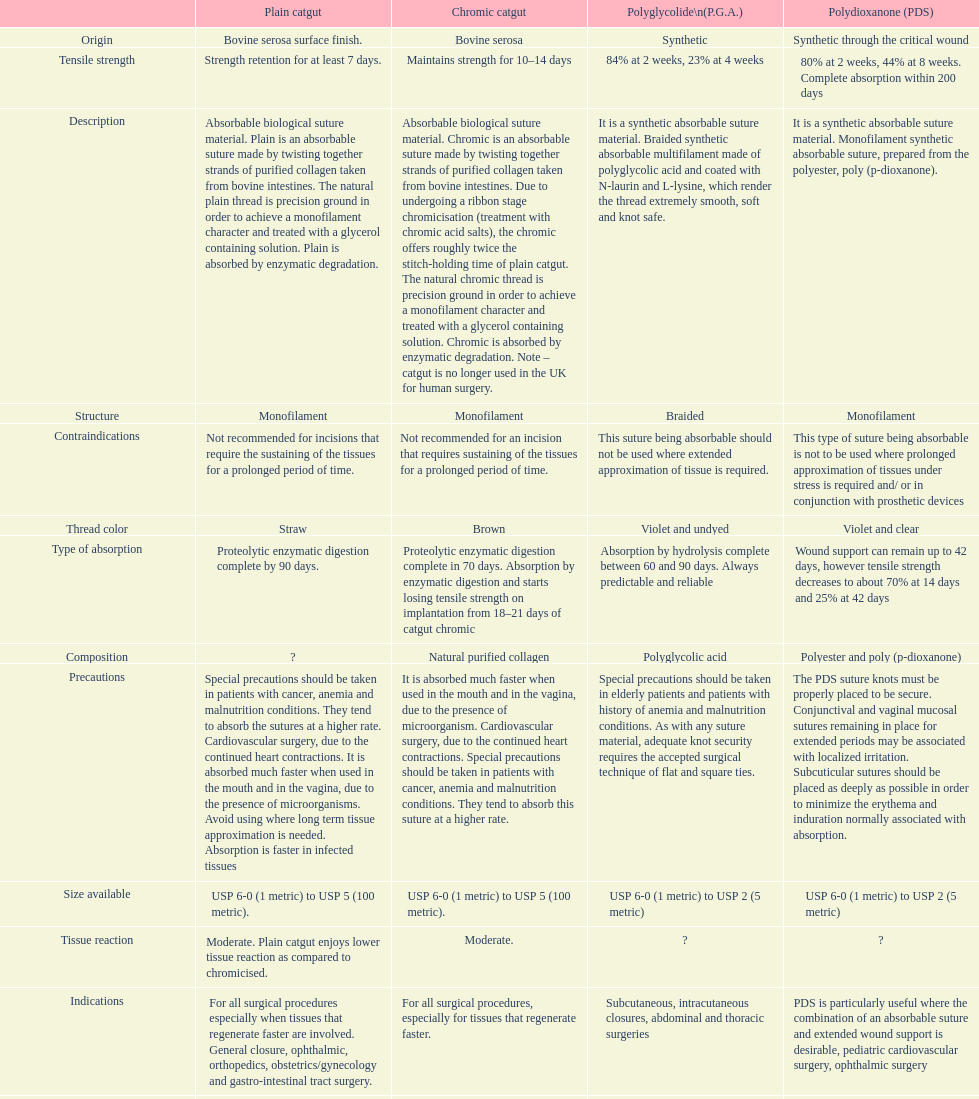I'm looking to parse the entire table for insights. Could you assist me with that? {'header': ['', 'Plain catgut', 'Chromic catgut', 'Polyglycolide\\n(P.G.A.)', 'Polydioxanone (PDS)'], 'rows': [['Origin', 'Bovine serosa surface finish.', 'Bovine serosa', 'Synthetic', 'Synthetic through the critical wound'], ['Tensile strength', 'Strength retention for at least 7 days.', 'Maintains strength for 10–14 days', '84% at 2 weeks, 23% at 4 weeks', '80% at 2 weeks, 44% at 8 weeks. Complete absorption within 200 days'], ['Description', 'Absorbable biological suture material. Plain is an absorbable suture made by twisting together strands of purified collagen taken from bovine intestines. The natural plain thread is precision ground in order to achieve a monofilament character and treated with a glycerol containing solution. Plain is absorbed by enzymatic degradation.', 'Absorbable biological suture material. Chromic is an absorbable suture made by twisting together strands of purified collagen taken from bovine intestines. Due to undergoing a ribbon stage chromicisation (treatment with chromic acid salts), the chromic offers roughly twice the stitch-holding time of plain catgut. The natural chromic thread is precision ground in order to achieve a monofilament character and treated with a glycerol containing solution. Chromic is absorbed by enzymatic degradation. Note – catgut is no longer used in the UK for human surgery.', 'It is a synthetic absorbable suture material. Braided synthetic absorbable multifilament made of polyglycolic acid and coated with N-laurin and L-lysine, which render the thread extremely smooth, soft and knot safe.', 'It is a synthetic absorbable suture material. Monofilament synthetic absorbable suture, prepared from the polyester, poly (p-dioxanone).'], ['Structure', 'Monofilament', 'Monofilament', 'Braided', 'Monofilament'], ['Contraindications', 'Not recommended for incisions that require the sustaining of the tissues for a prolonged period of time.', 'Not recommended for an incision that requires sustaining of the tissues for a prolonged period of time.', 'This suture being absorbable should not be used where extended approximation of tissue is required.', 'This type of suture being absorbable is not to be used where prolonged approximation of tissues under stress is required and/ or in conjunction with prosthetic devices'], ['Thread color', 'Straw', 'Brown', 'Violet and undyed', 'Violet and clear'], ['Type of absorption', 'Proteolytic enzymatic digestion complete by 90 days.', 'Proteolytic enzymatic digestion complete in 70 days. Absorption by enzymatic digestion and starts losing tensile strength on implantation from 18–21 days of catgut chromic', 'Absorption by hydrolysis complete between 60 and 90 days. Always predictable and reliable', 'Wound support can remain up to 42 days, however tensile strength decreases to about 70% at 14 days and 25% at 42 days'], ['Composition', '?', 'Natural purified collagen', 'Polyglycolic acid', 'Polyester and poly (p-dioxanone)'], ['Precautions', 'Special precautions should be taken in patients with cancer, anemia and malnutrition conditions. They tend to absorb the sutures at a higher rate. Cardiovascular surgery, due to the continued heart contractions. It is absorbed much faster when used in the mouth and in the vagina, due to the presence of microorganisms. Avoid using where long term tissue approximation is needed. Absorption is faster in infected tissues', 'It is absorbed much faster when used in the mouth and in the vagina, due to the presence of microorganism. Cardiovascular surgery, due to the continued heart contractions. Special precautions should be taken in patients with cancer, anemia and malnutrition conditions. They tend to absorb this suture at a higher rate.', 'Special precautions should be taken in elderly patients and patients with history of anemia and malnutrition conditions. As with any suture material, adequate knot security requires the accepted surgical technique of flat and square ties.', 'The PDS suture knots must be properly placed to be secure. Conjunctival and vaginal mucosal sutures remaining in place for extended periods may be associated with localized irritation. Subcuticular sutures should be placed as deeply as possible in order to minimize the erythema and induration normally associated with absorption.'], ['Size available', 'USP 6-0 (1 metric) to USP 5 (100 metric).', 'USP 6-0 (1 metric) to USP 5 (100 metric).', 'USP 6-0 (1 metric) to USP 2 (5 metric)', 'USP 6-0 (1 metric) to USP 2 (5 metric)'], ['Tissue reaction', 'Moderate. Plain catgut enjoys lower tissue reaction as compared to chromicised.', 'Moderate.', '?', '?'], ['Indications', 'For all surgical procedures especially when tissues that regenerate faster are involved. General closure, ophthalmic, orthopedics, obstetrics/gynecology and gastro-intestinal tract surgery.', 'For all surgical procedures, especially for tissues that regenerate faster.', 'Subcutaneous, intracutaneous closures, abdominal and thoracic surgeries', 'PDS is particularly useful where the combination of an absorbable suture and extended wound support is desirable, pediatric cardiovascular surgery, ophthalmic surgery'], ['Treatment', '?', 'Treatment with a glycerol containing solution and chromic acid salts', 'Coated with magnesium stearate', 'Uncoated'], ['Advantages', 'Very high knot-pull tensile strength, good knot security due to special excellent handling features', 'Very high knot-pull tensile strength, good knot security due to special surface finish, improved smoothness due to the dry presentation of the thread, excellent handling features', 'High initial tensile strength, guaranteed holding power through the critical wound healing period. Smooth passage through tissue, easy handling, excellent knotting ability, secure knot tying', 'Tensile strength retention, guaranteed holding power'], ['Sterilization', 'Sterilizing fluid containing EO', 'Sterilizing fluid containing EO', 'E.O. gas.', 'E.O. gas']]} Plain catgut and chromic catgut both have what type of structure? Monofilament. 